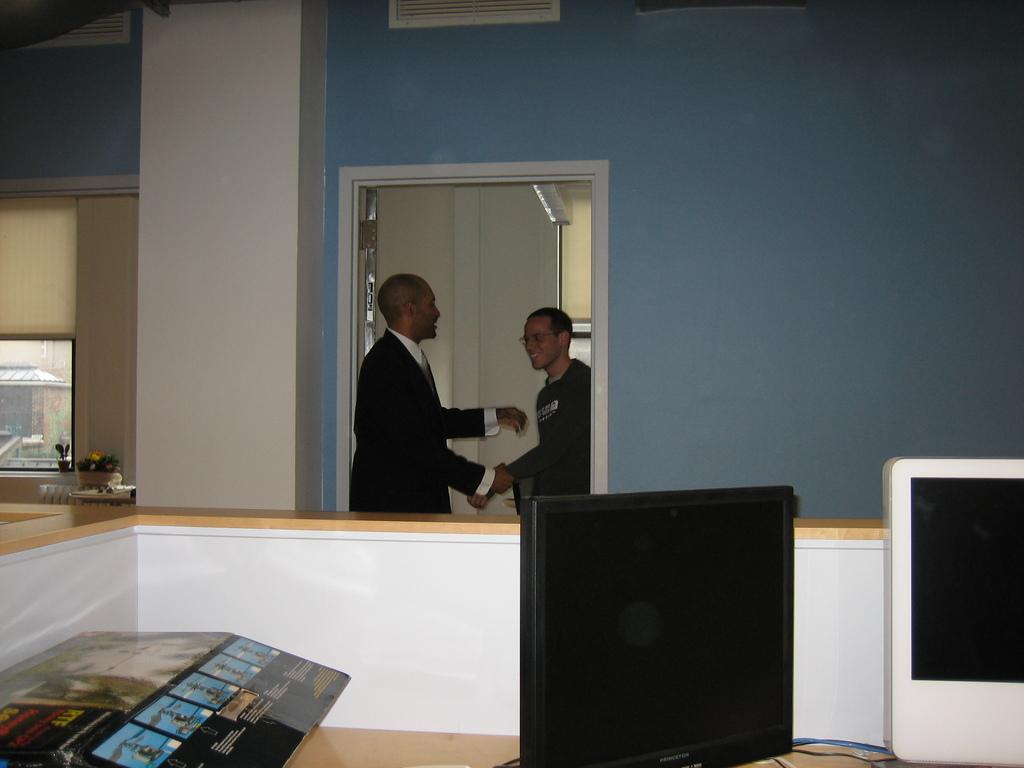What are the two persons in the image doing? The two persons in the image are standing and talking. Where are the persons located in the image? The persons are at a door. What object can be seen on a table in the image? There is a computer on a table in the image. What type of plant is visible near a window in the image? There is a houseplant at a window on the left side of the image. What type of stocking is hanging on the door in the image? There is no stocking hanging on the door in the image. 